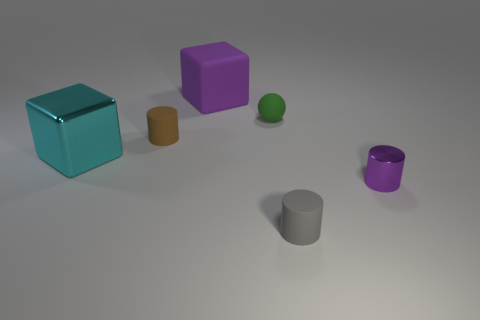Subtract all purple cylinders. How many cylinders are left? 2 Subtract all rubber cylinders. How many cylinders are left? 1 Subtract 1 spheres. How many spheres are left? 0 Add 1 small balls. How many small balls are left? 2 Add 3 big gray balls. How many big gray balls exist? 3 Add 2 large purple matte cubes. How many objects exist? 8 Subtract 0 green cylinders. How many objects are left? 6 Subtract all balls. How many objects are left? 5 Subtract all blue spheres. Subtract all green blocks. How many spheres are left? 1 Subtract all red cubes. How many yellow balls are left? 0 